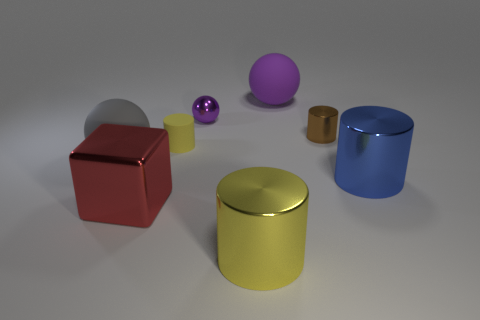Subtract all brown cylinders. How many cylinders are left? 3 Subtract all tiny brown shiny cylinders. How many cylinders are left? 3 Subtract all gray cylinders. Subtract all cyan spheres. How many cylinders are left? 4 Add 1 large blue objects. How many objects exist? 9 Subtract all spheres. How many objects are left? 5 Add 6 tiny purple shiny things. How many tiny purple shiny things exist? 7 Subtract 0 blue spheres. How many objects are left? 8 Subtract all cyan matte spheres. Subtract all tiny yellow rubber cylinders. How many objects are left? 7 Add 6 big cylinders. How many big cylinders are left? 8 